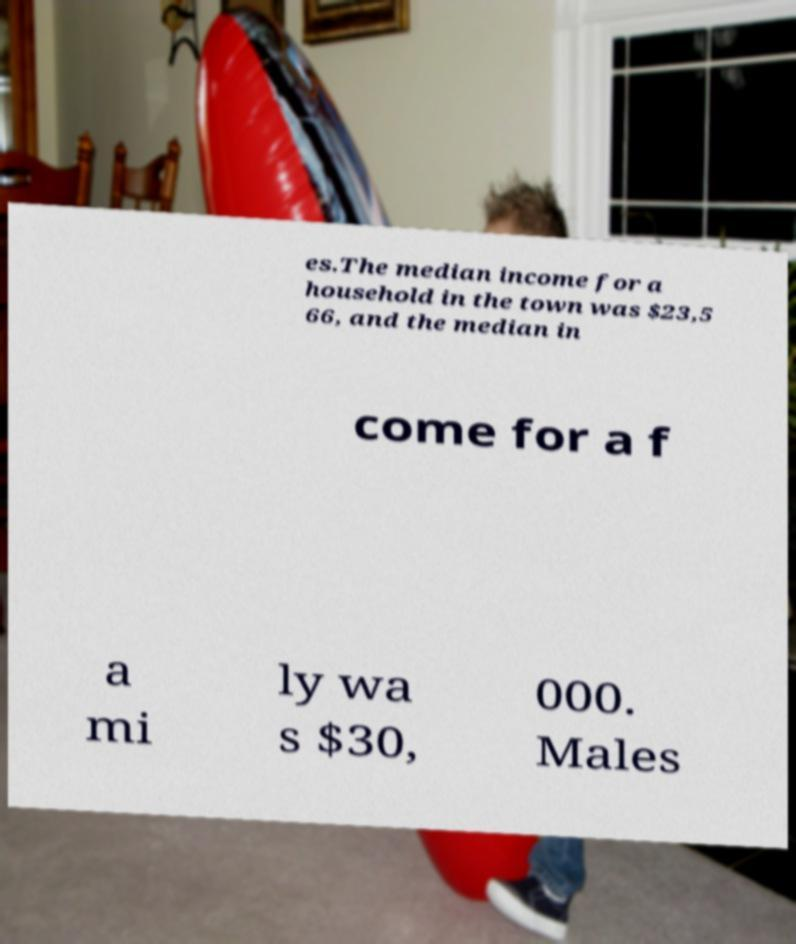What messages or text are displayed in this image? I need them in a readable, typed format. es.The median income for a household in the town was $23,5 66, and the median in come for a f a mi ly wa s $30, 000. Males 